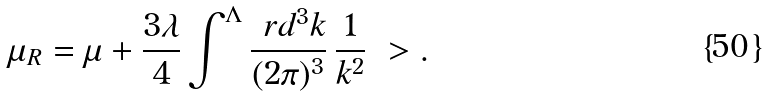Convert formula to latex. <formula><loc_0><loc_0><loc_500><loc_500>\mu _ { R } = \mu + \frac { 3 \lambda } { 4 } \int ^ { \Lambda } \frac { \ r d ^ { 3 } k } { ( 2 \pi ) ^ { 3 } } \, \frac { 1 } { k ^ { 2 } } \ > .</formula> 